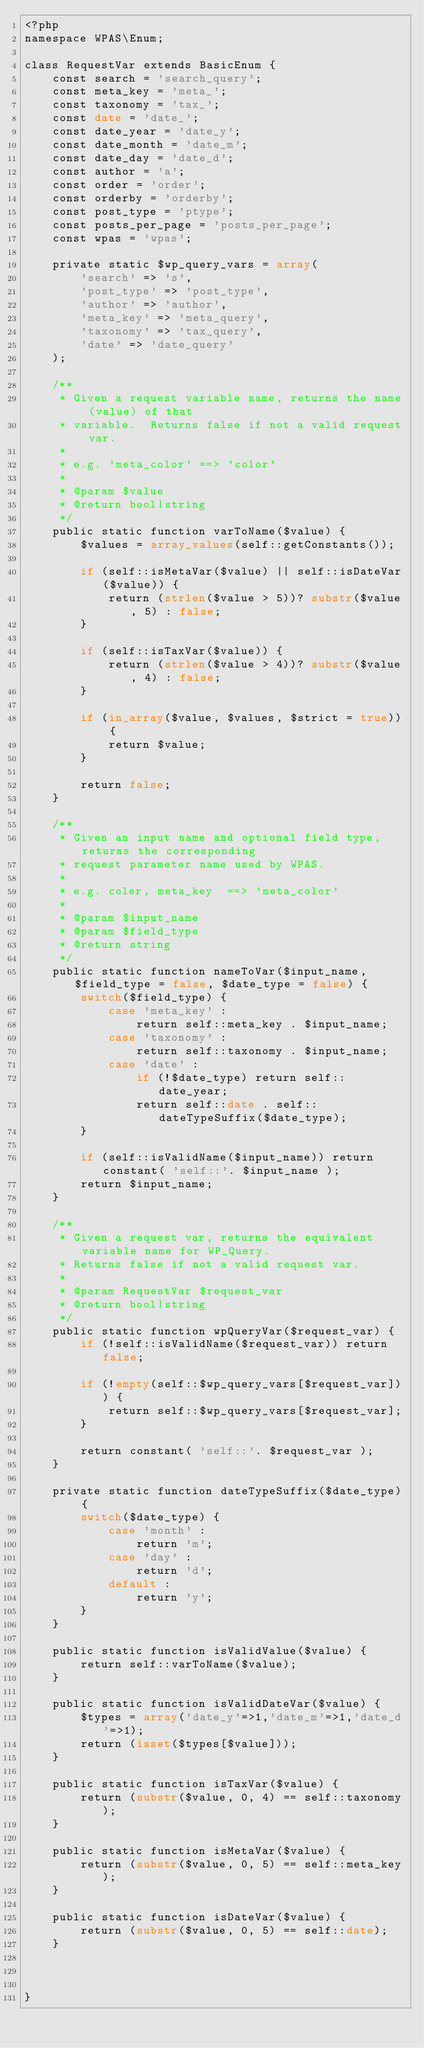<code> <loc_0><loc_0><loc_500><loc_500><_PHP_><?php
namespace WPAS\Enum;

class RequestVar extends BasicEnum {
    const search = 'search_query';
    const meta_key = 'meta_';
    const taxonomy = 'tax_';
    const date = 'date_';
    const date_year = 'date_y';
    const date_month = 'date_m';
    const date_day = 'date_d';
    const author = 'a';
    const order = 'order';
    const orderby = 'orderby';
    const post_type = 'ptype';
    const posts_per_page = 'posts_per_page';
    const wpas = 'wpas';

    private static $wp_query_vars = array(
        'search' => 's',
        'post_type' => 'post_type',
        'author' => 'author',
        'meta_key' => 'meta_query',
        'taxonomy' => 'tax_query',
        'date' => 'date_query'
    );

    /**
     * Given a request variable name, returns the name (value) of that
     * variable.  Returns false if not a valid request var.
     *
     * e.g. 'meta_color' ==> 'color'
     *
     * @param $value
     * @return bool|string
     */
    public static function varToName($value) {
        $values = array_values(self::getConstants());

        if (self::isMetaVar($value) || self::isDateVar($value)) {
            return (strlen($value > 5))? substr($value, 5) : false;
        }

        if (self::isTaxVar($value)) {
            return (strlen($value > 4))? substr($value, 4) : false;
        }

        if (in_array($value, $values, $strict = true)) {
            return $value;
        }

        return false;
    }

    /**
     * Given an input name and optional field type, returns the corresponding
     * request parameter name used by WPAS.
     *
     * e.g. color, meta_key  ==> 'meta_color'
     *
     * @param $input_name
     * @param $field_type
     * @return string
     */
    public static function nameToVar($input_name, $field_type = false, $date_type = false) {
        switch($field_type) {
            case 'meta_key' :
                return self::meta_key . $input_name;
            case 'taxonomy' :
                return self::taxonomy . $input_name;
            case 'date' :
                if (!$date_type) return self::date_year;
                return self::date . self::dateTypeSuffix($date_type);
        }

        if (self::isValidName($input_name)) return constant( 'self::'. $input_name );
        return $input_name;
    }

    /**
     * Given a request var, returns the equivalent variable name for WP_Query.
     * Returns false if not a valid request var.
     *
     * @param RequestVar $request_var
     * @return bool|string
     */
    public static function wpQueryVar($request_var) {
        if (!self::isValidName($request_var)) return false;

        if (!empty(self::$wp_query_vars[$request_var])) {
            return self::$wp_query_vars[$request_var];
        }

        return constant( 'self::'. $request_var );
    }

    private static function dateTypeSuffix($date_type) {
        switch($date_type) {
            case 'month' :
                return 'm';
            case 'day' :
                return 'd';
            default :
                return 'y';
        }
    }

    public static function isValidValue($value) {
        return self::varToName($value);
    }

    public static function isValidDateVar($value) {
        $types = array('date_y'=>1,'date_m'=>1,'date_d'=>1);
        return (isset($types[$value]));
    }

    public static function isTaxVar($value) {
        return (substr($value, 0, 4) == self::taxonomy);
    }

    public static function isMetaVar($value) {
        return (substr($value, 0, 5) == self::meta_key);
    }

    public static function isDateVar($value) {
        return (substr($value, 0, 5) == self::date);
    }



}</code> 